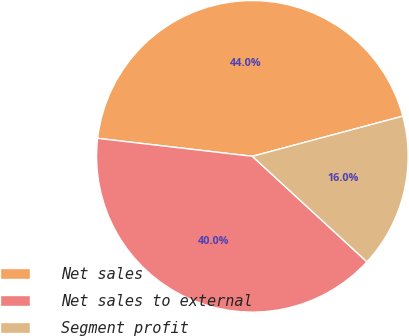<chart> <loc_0><loc_0><loc_500><loc_500><pie_chart><fcel>Net sales<fcel>Net sales to external<fcel>Segment profit<nl><fcel>44.0%<fcel>40.0%<fcel>16.0%<nl></chart> 